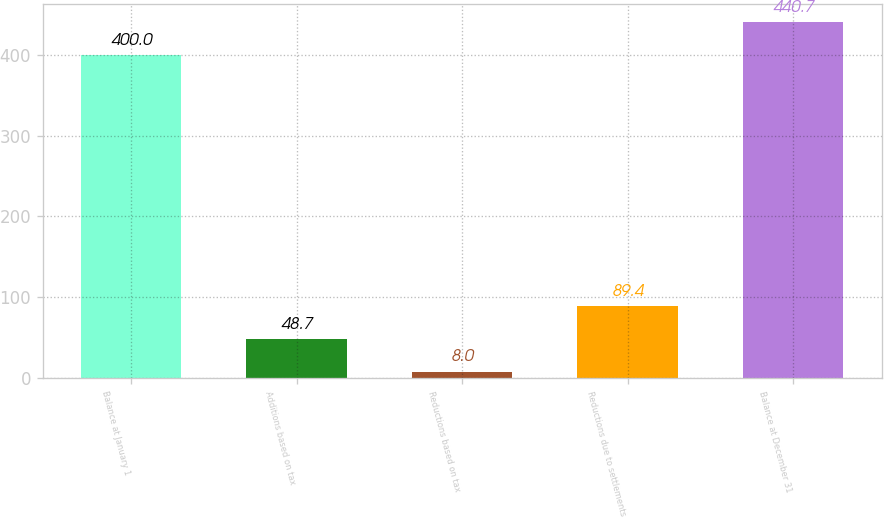Convert chart to OTSL. <chart><loc_0><loc_0><loc_500><loc_500><bar_chart><fcel>Balance at January 1<fcel>Additions based on tax<fcel>Reductions based on tax<fcel>Reductions due to settlements<fcel>Balance at December 31<nl><fcel>400<fcel>48.7<fcel>8<fcel>89.4<fcel>440.7<nl></chart> 